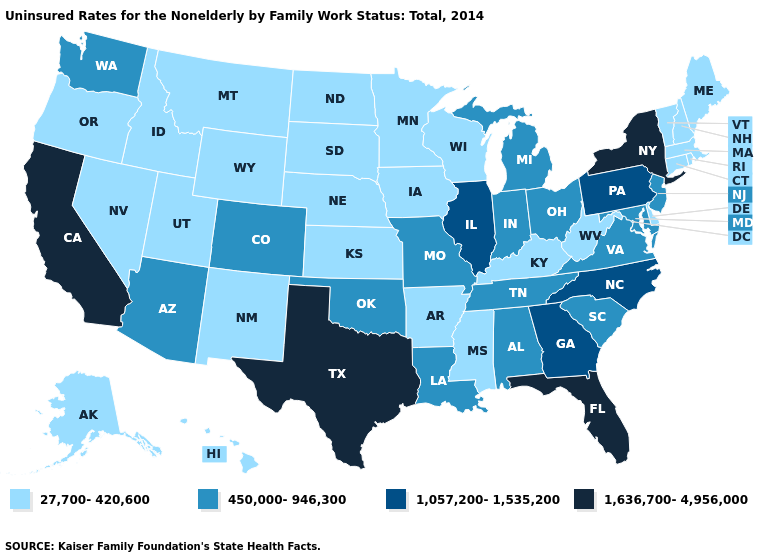Does Texas have the highest value in the USA?
Be succinct. Yes. What is the lowest value in the MidWest?
Be succinct. 27,700-420,600. What is the value of New Hampshire?
Short answer required. 27,700-420,600. Does New York have the highest value in the USA?
Concise answer only. Yes. What is the value of Pennsylvania?
Write a very short answer. 1,057,200-1,535,200. What is the highest value in the West ?
Be succinct. 1,636,700-4,956,000. Which states hav the highest value in the MidWest?
Give a very brief answer. Illinois. Does Nebraska have the same value as South Carolina?
Write a very short answer. No. What is the value of Pennsylvania?
Keep it brief. 1,057,200-1,535,200. What is the value of Florida?
Short answer required. 1,636,700-4,956,000. Name the states that have a value in the range 1,057,200-1,535,200?
Quick response, please. Georgia, Illinois, North Carolina, Pennsylvania. Does Illinois have the same value as North Carolina?
Answer briefly. Yes. Does Florida have the highest value in the South?
Concise answer only. Yes. What is the value of Georgia?
Keep it brief. 1,057,200-1,535,200. What is the highest value in the West ?
Give a very brief answer. 1,636,700-4,956,000. 